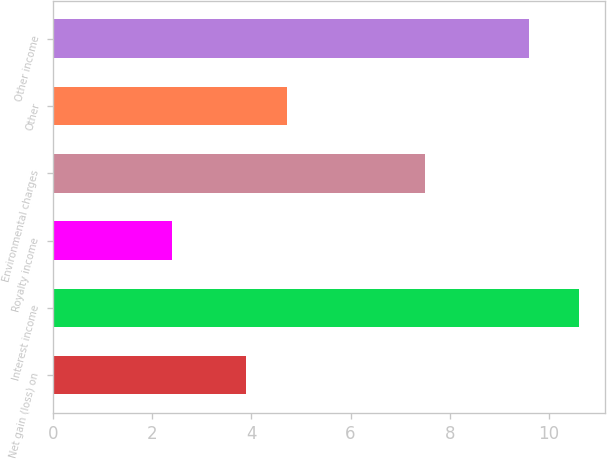Convert chart. <chart><loc_0><loc_0><loc_500><loc_500><bar_chart><fcel>Net gain (loss) on<fcel>Interest income<fcel>Royalty income<fcel>Environmental charges<fcel>Other<fcel>Other income<nl><fcel>3.9<fcel>10.6<fcel>2.4<fcel>7.5<fcel>4.72<fcel>9.6<nl></chart> 